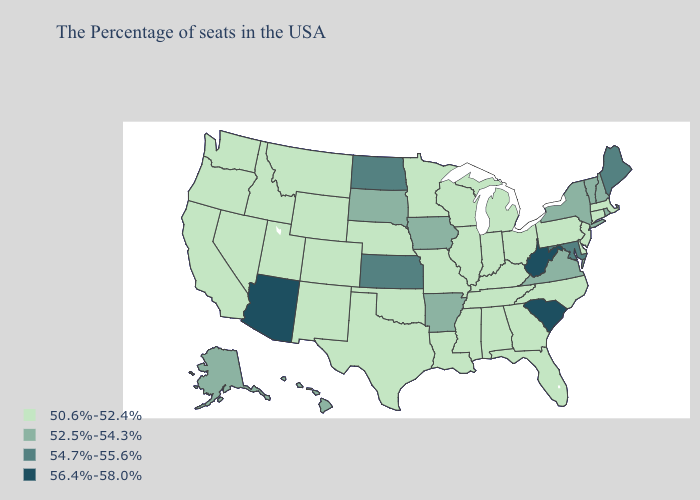Which states have the lowest value in the South?
Keep it brief. Delaware, North Carolina, Florida, Georgia, Kentucky, Alabama, Tennessee, Mississippi, Louisiana, Oklahoma, Texas. What is the highest value in the South ?
Quick response, please. 56.4%-58.0%. Does Mississippi have the lowest value in the South?
Give a very brief answer. Yes. What is the value of Arkansas?
Be succinct. 52.5%-54.3%. Which states have the lowest value in the USA?
Answer briefly. Massachusetts, Connecticut, New Jersey, Delaware, Pennsylvania, North Carolina, Ohio, Florida, Georgia, Michigan, Kentucky, Indiana, Alabama, Tennessee, Wisconsin, Illinois, Mississippi, Louisiana, Missouri, Minnesota, Nebraska, Oklahoma, Texas, Wyoming, Colorado, New Mexico, Utah, Montana, Idaho, Nevada, California, Washington, Oregon. Does the first symbol in the legend represent the smallest category?
Give a very brief answer. Yes. Name the states that have a value in the range 54.7%-55.6%?
Keep it brief. Maine, Maryland, Kansas, North Dakota. What is the value of Rhode Island?
Concise answer only. 52.5%-54.3%. Among the states that border Virginia , does West Virginia have the highest value?
Answer briefly. Yes. What is the value of Nebraska?
Give a very brief answer. 50.6%-52.4%. Name the states that have a value in the range 56.4%-58.0%?
Give a very brief answer. South Carolina, West Virginia, Arizona. What is the highest value in states that border Maryland?
Keep it brief. 56.4%-58.0%. What is the value of Rhode Island?
Write a very short answer. 52.5%-54.3%. What is the value of Montana?
Concise answer only. 50.6%-52.4%. What is the lowest value in states that border Tennessee?
Quick response, please. 50.6%-52.4%. 